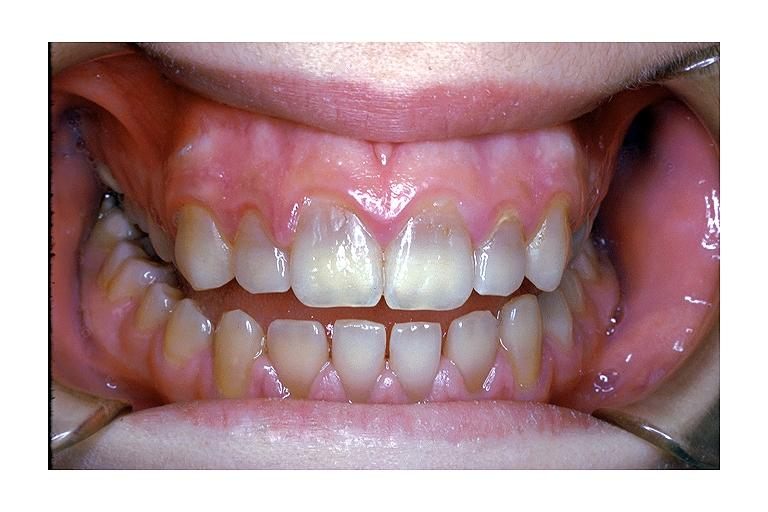s inflamed exocervix present?
Answer the question using a single word or phrase. No 